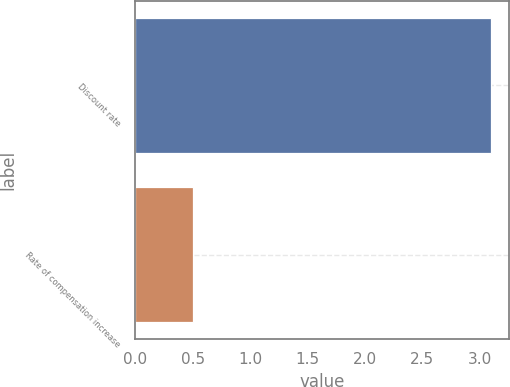Convert chart to OTSL. <chart><loc_0><loc_0><loc_500><loc_500><bar_chart><fcel>Discount rate<fcel>Rate of compensation increase<nl><fcel>3.1<fcel>0.5<nl></chart> 